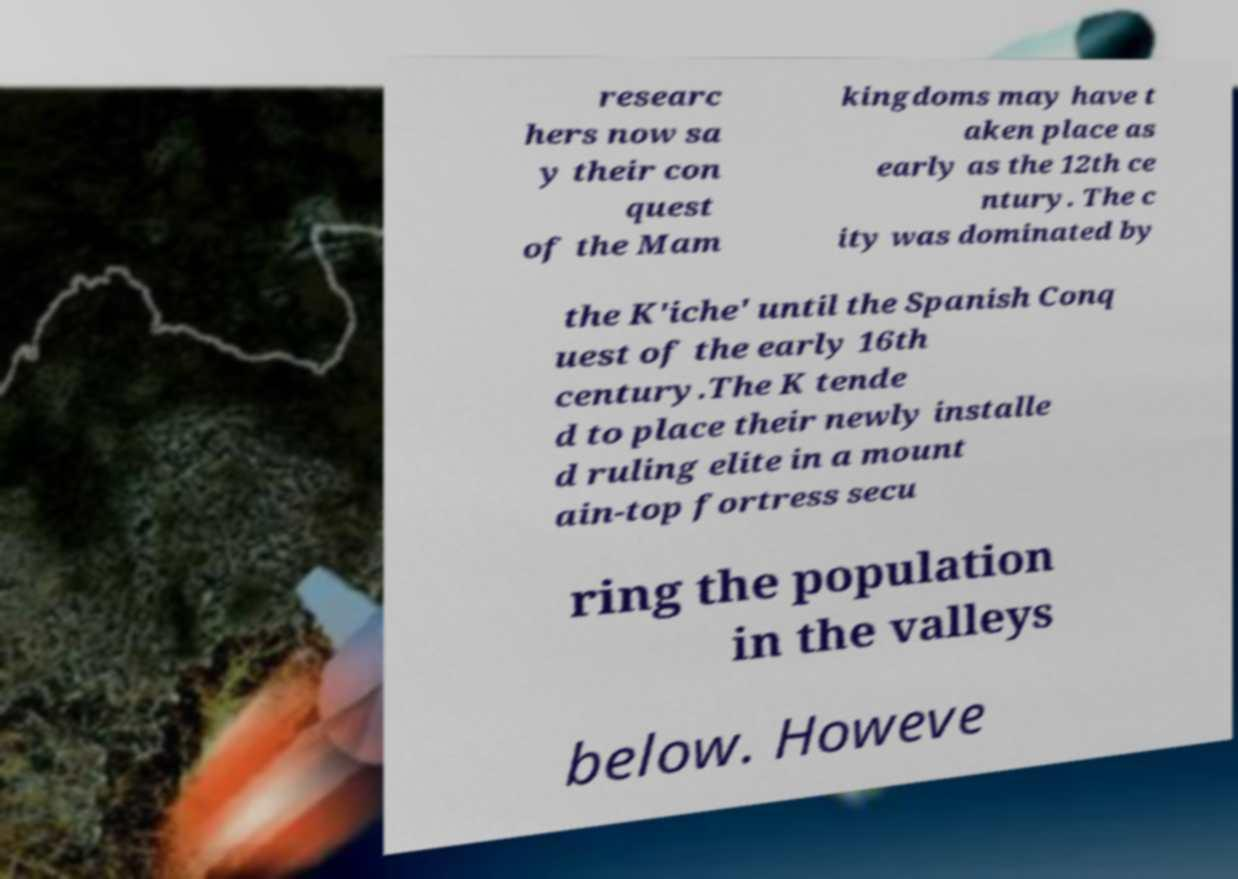I need the written content from this picture converted into text. Can you do that? researc hers now sa y their con quest of the Mam kingdoms may have t aken place as early as the 12th ce ntury. The c ity was dominated by the K'iche' until the Spanish Conq uest of the early 16th century.The K tende d to place their newly installe d ruling elite in a mount ain-top fortress secu ring the population in the valleys below. Howeve 